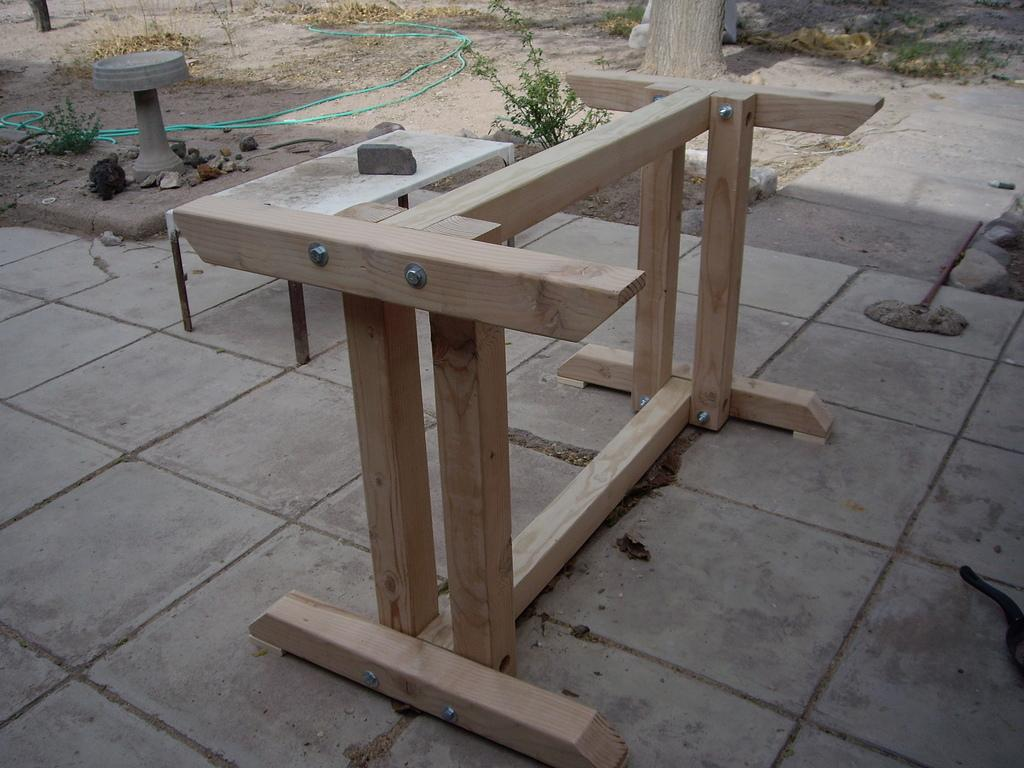What is the main structure in the image? There is a wooden stand in the image. What can be seen attached to the wooden stand? There is a pipe in the image. What type of living organisms are present in the image? There are plants in the image. What is placed on the wooden stand? There is a stone placed on the stand. What can be seen in the background of the image? There is a tree in the background of the image. How many vases are visible in the image? There are no vases present in the image. What is the fifth object in the image? The provided facts do not indicate a fifth object in the image. 